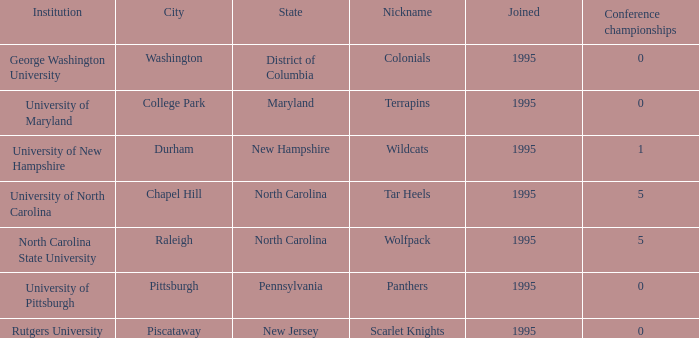What is the earliest year joined in the city of college park at the conference championships less than 0? None. Parse the table in full. {'header': ['Institution', 'City', 'State', 'Nickname', 'Joined', 'Conference championships'], 'rows': [['George Washington University', 'Washington', 'District of Columbia', 'Colonials', '1995', '0'], ['University of Maryland', 'College Park', 'Maryland', 'Terrapins', '1995', '0'], ['University of New Hampshire', 'Durham', 'New Hampshire', 'Wildcats', '1995', '1'], ['University of North Carolina', 'Chapel Hill', 'North Carolina', 'Tar Heels', '1995', '5'], ['North Carolina State University', 'Raleigh', 'North Carolina', 'Wolfpack', '1995', '5'], ['University of Pittsburgh', 'Pittsburgh', 'Pennsylvania', 'Panthers', '1995', '0'], ['Rutgers University', 'Piscataway', 'New Jersey', 'Scarlet Knights', '1995', '0']]} 